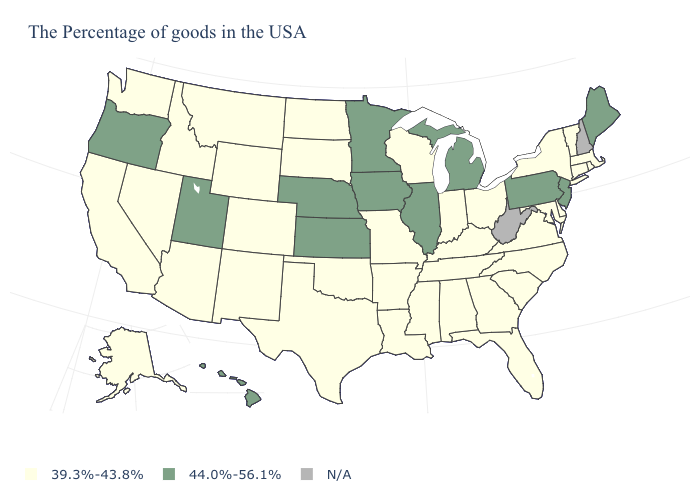What is the lowest value in the USA?
Keep it brief. 39.3%-43.8%. Which states have the highest value in the USA?
Be succinct. Maine, New Jersey, Pennsylvania, Michigan, Illinois, Minnesota, Iowa, Kansas, Nebraska, Utah, Oregon, Hawaii. What is the value of Georgia?
Concise answer only. 39.3%-43.8%. Name the states that have a value in the range 39.3%-43.8%?
Concise answer only. Massachusetts, Rhode Island, Vermont, Connecticut, New York, Delaware, Maryland, Virginia, North Carolina, South Carolina, Ohio, Florida, Georgia, Kentucky, Indiana, Alabama, Tennessee, Wisconsin, Mississippi, Louisiana, Missouri, Arkansas, Oklahoma, Texas, South Dakota, North Dakota, Wyoming, Colorado, New Mexico, Montana, Arizona, Idaho, Nevada, California, Washington, Alaska. What is the value of Mississippi?
Concise answer only. 39.3%-43.8%. What is the highest value in the MidWest ?
Give a very brief answer. 44.0%-56.1%. Does Nebraska have the lowest value in the USA?
Quick response, please. No. Name the states that have a value in the range 39.3%-43.8%?
Write a very short answer. Massachusetts, Rhode Island, Vermont, Connecticut, New York, Delaware, Maryland, Virginia, North Carolina, South Carolina, Ohio, Florida, Georgia, Kentucky, Indiana, Alabama, Tennessee, Wisconsin, Mississippi, Louisiana, Missouri, Arkansas, Oklahoma, Texas, South Dakota, North Dakota, Wyoming, Colorado, New Mexico, Montana, Arizona, Idaho, Nevada, California, Washington, Alaska. What is the value of Missouri?
Answer briefly. 39.3%-43.8%. Among the states that border New Hampshire , does Maine have the highest value?
Be succinct. Yes. What is the lowest value in states that border Vermont?
Give a very brief answer. 39.3%-43.8%. What is the value of Nevada?
Give a very brief answer. 39.3%-43.8%. What is the value of Florida?
Keep it brief. 39.3%-43.8%. 